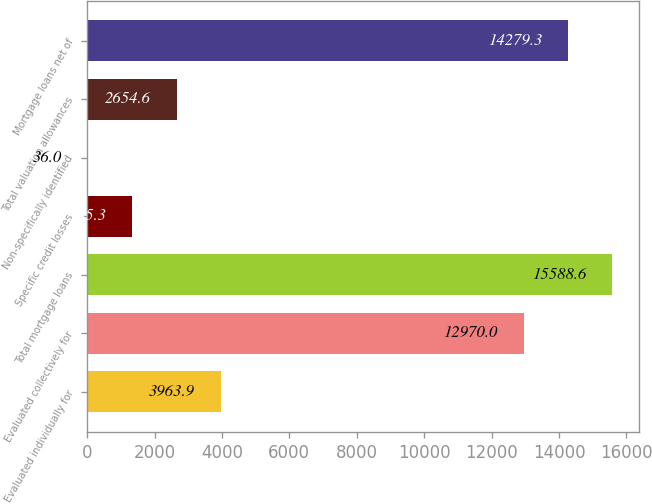Convert chart to OTSL. <chart><loc_0><loc_0><loc_500><loc_500><bar_chart><fcel>Evaluated individually for<fcel>Evaluated collectively for<fcel>Total mortgage loans<fcel>Specific credit losses<fcel>Non-specifically identified<fcel>Total valuation allowances<fcel>Mortgage loans net of<nl><fcel>3963.9<fcel>12970<fcel>15588.6<fcel>1345.3<fcel>36<fcel>2654.6<fcel>14279.3<nl></chart> 